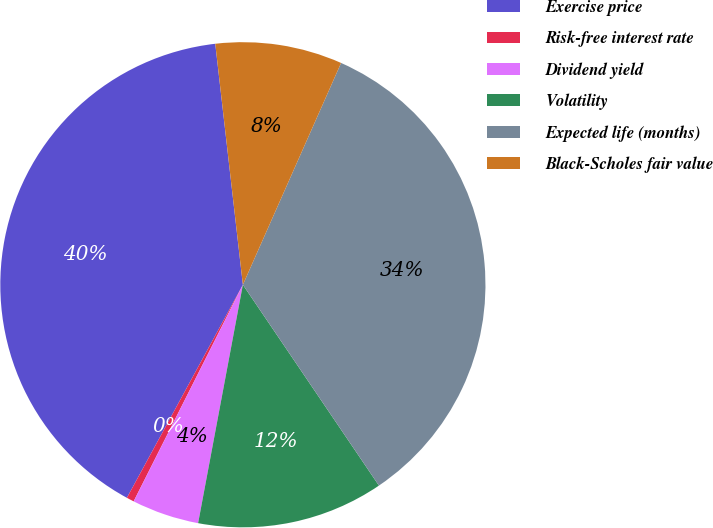Convert chart to OTSL. <chart><loc_0><loc_0><loc_500><loc_500><pie_chart><fcel>Exercise price<fcel>Risk-free interest rate<fcel>Dividend yield<fcel>Volatility<fcel>Expected life (months)<fcel>Black-Scholes fair value<nl><fcel>40.25%<fcel>0.5%<fcel>4.48%<fcel>12.43%<fcel>33.89%<fcel>8.45%<nl></chart> 